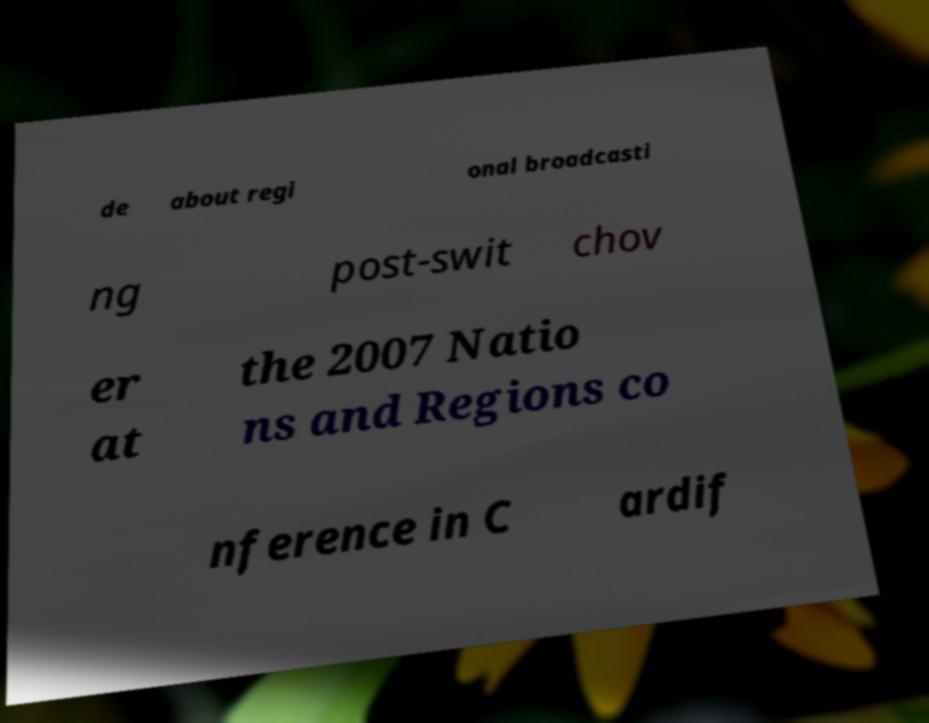Please read and relay the text visible in this image. What does it say? de about regi onal broadcasti ng post-swit chov er at the 2007 Natio ns and Regions co nference in C ardif 